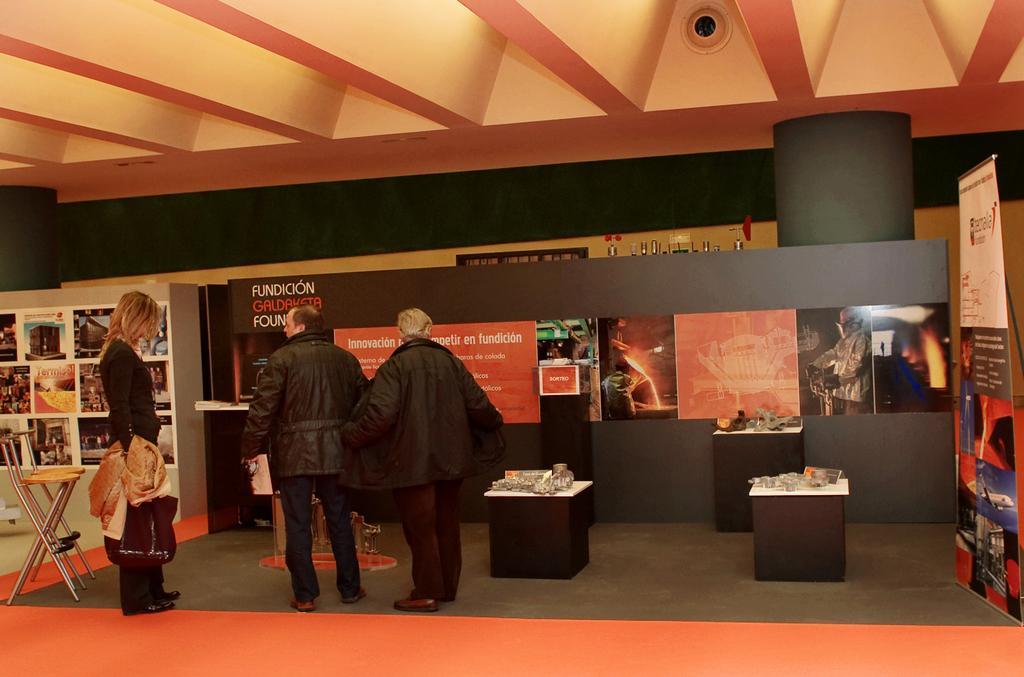Can you describe this image briefly? This is a banner at the right side of the picture. On the table we can see glasse and few products. This is a floor. We can see three persons standing near to the chair. We can see the posts here. 